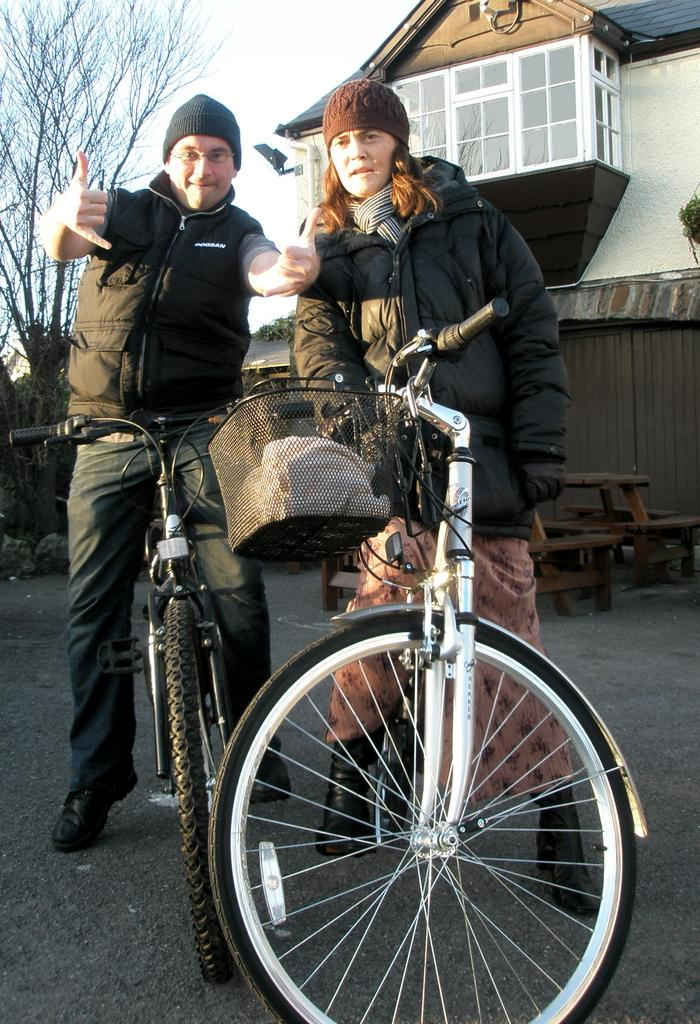What are the two people in the image doing? There is a man and a woman on bicycles in the image. What can be seen in the background of the image? There is a sky, a tree, and a building visible in the background of the image. What type of seating is present in the image? There are benches in the image. What type of barrier is present in the image? There is a fence wall in the image. What is the price of the yard in the image? There is no yard present in the image, so it is not possible to determine its price. 